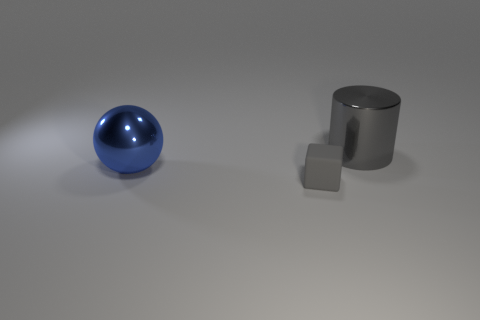Add 2 big gray shiny cylinders. How many objects exist? 5 Subtract all cylinders. How many objects are left? 2 Add 1 blue metallic objects. How many blue metallic objects are left? 2 Add 3 green objects. How many green objects exist? 3 Subtract 0 cyan spheres. How many objects are left? 3 Subtract all big yellow matte blocks. Subtract all small matte things. How many objects are left? 2 